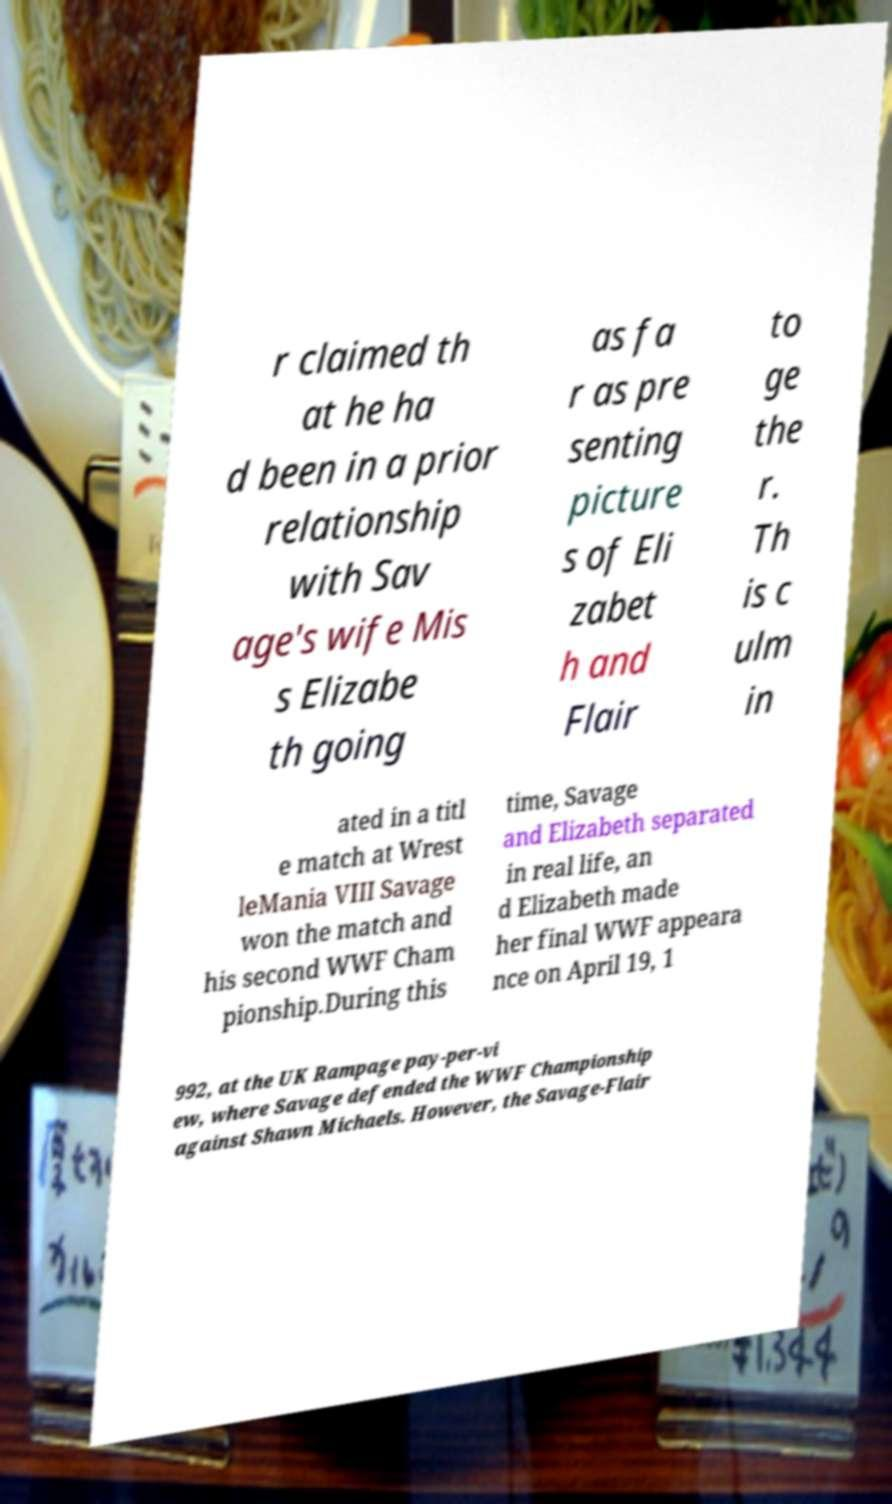Can you accurately transcribe the text from the provided image for me? r claimed th at he ha d been in a prior relationship with Sav age's wife Mis s Elizabe th going as fa r as pre senting picture s of Eli zabet h and Flair to ge the r. Th is c ulm in ated in a titl e match at Wrest leMania VIII Savage won the match and his second WWF Cham pionship.During this time, Savage and Elizabeth separated in real life, an d Elizabeth made her final WWF appeara nce on April 19, 1 992, at the UK Rampage pay-per-vi ew, where Savage defended the WWF Championship against Shawn Michaels. However, the Savage-Flair 